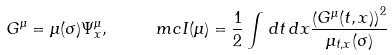Convert formula to latex. <formula><loc_0><loc_0><loc_500><loc_500>G ^ { \mu } = \mu ( \sigma ) \Psi ^ { \mu } _ { x } , \quad \ m c I ( \mu ) = \frac { 1 } { 2 } \int \, d t \, d x \frac { \left ( G ^ { \mu } ( t , x ) \right ) ^ { 2 } } { \mu _ { t , x } ( \sigma ) }</formula> 